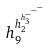<formula> <loc_0><loc_0><loc_500><loc_500>h _ { 9 } ^ { h _ { 2 } ^ { h _ { 3 } ^ { - ^ { - ^ { - } } } } }</formula> 